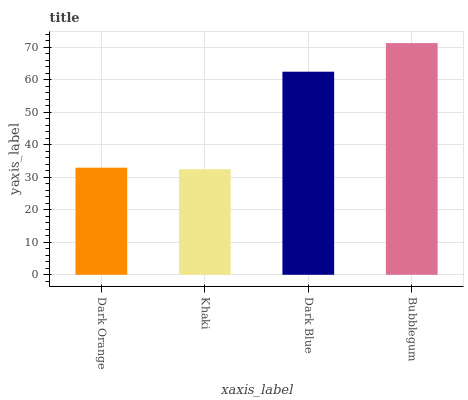Is Khaki the minimum?
Answer yes or no. Yes. Is Bubblegum the maximum?
Answer yes or no. Yes. Is Dark Blue the minimum?
Answer yes or no. No. Is Dark Blue the maximum?
Answer yes or no. No. Is Dark Blue greater than Khaki?
Answer yes or no. Yes. Is Khaki less than Dark Blue?
Answer yes or no. Yes. Is Khaki greater than Dark Blue?
Answer yes or no. No. Is Dark Blue less than Khaki?
Answer yes or no. No. Is Dark Blue the high median?
Answer yes or no. Yes. Is Dark Orange the low median?
Answer yes or no. Yes. Is Bubblegum the high median?
Answer yes or no. No. Is Dark Blue the low median?
Answer yes or no. No. 